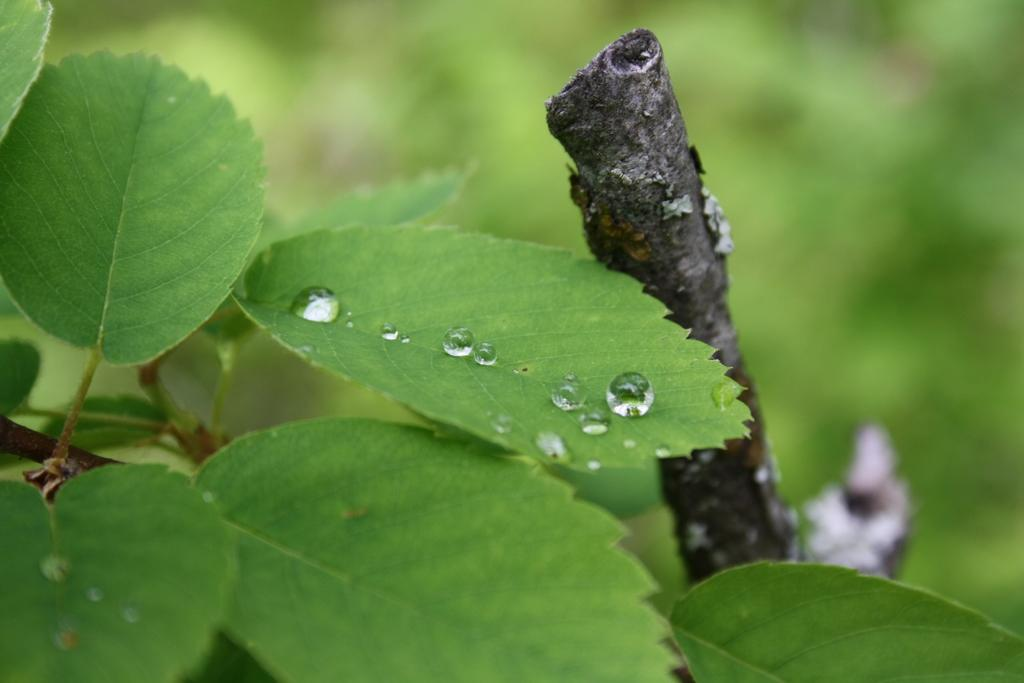What is the main subject in the center of the image? There are leaves in the center of the image. What part of the plant is visible in the image? There is a stem in the image. How would you describe the background of the image? The background of the image is blurred. What type of quartz can be seen in the image? There is no quartz present in the image; it features leaves and a stem. Can you tell me how the dad is interacting with the leaves in the image? There is no person, including a dad, present in the image. 